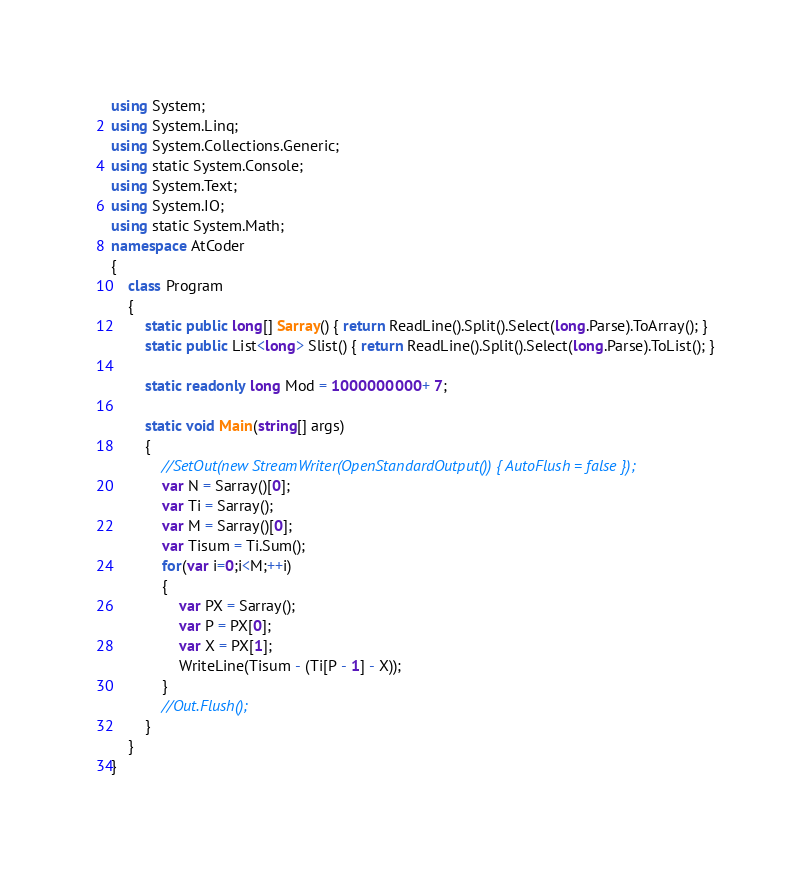Convert code to text. <code><loc_0><loc_0><loc_500><loc_500><_C#_>using System;
using System.Linq;
using System.Collections.Generic;
using static System.Console;
using System.Text;
using System.IO;
using static System.Math;
namespace AtCoder
{
    class Program
    {
        static public long[] Sarray() { return ReadLine().Split().Select(long.Parse).ToArray(); }
        static public List<long> Slist() { return ReadLine().Split().Select(long.Parse).ToList(); }

        static readonly long Mod = 1000000000 + 7;

        static void Main(string[] args)
        {
            //SetOut(new StreamWriter(OpenStandardOutput()) { AutoFlush = false });
            var N = Sarray()[0];
            var Ti = Sarray();
            var M = Sarray()[0];
            var Tisum = Ti.Sum();
            for(var i=0;i<M;++i)
            {
                var PX = Sarray();
                var P = PX[0];
                var X = PX[1];
                WriteLine(Tisum - (Ti[P - 1] - X));
            }
            //Out.Flush();
        }
    }
}</code> 